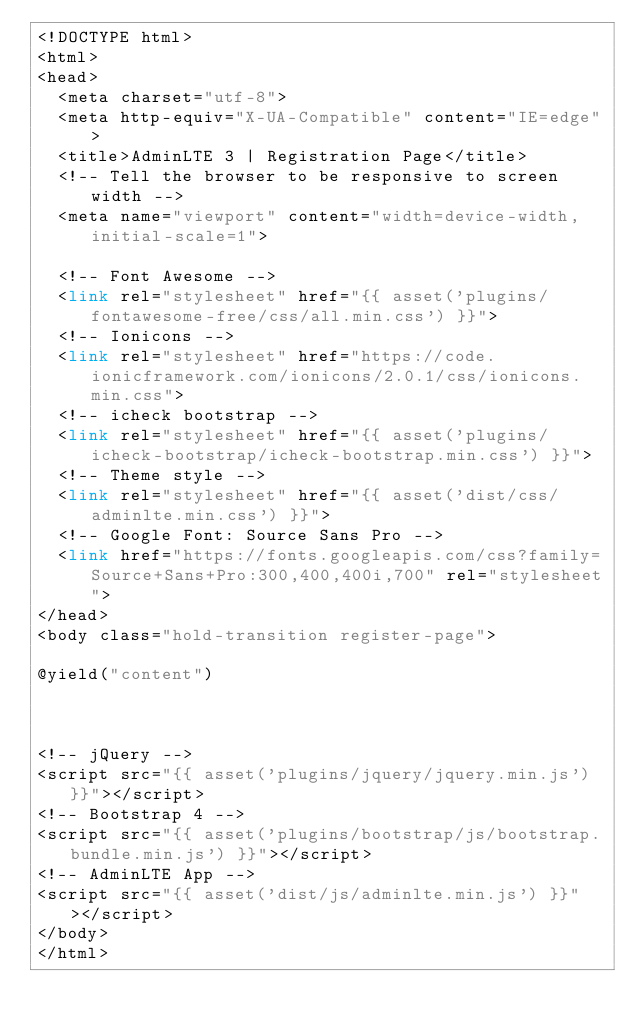Convert code to text. <code><loc_0><loc_0><loc_500><loc_500><_PHP_><!DOCTYPE html>
<html>
<head>
  <meta charset="utf-8">
  <meta http-equiv="X-UA-Compatible" content="IE=edge">
  <title>AdminLTE 3 | Registration Page</title>
  <!-- Tell the browser to be responsive to screen width -->
  <meta name="viewport" content="width=device-width, initial-scale=1">

  <!-- Font Awesome -->
  <link rel="stylesheet" href="{{ asset('plugins/fontawesome-free/css/all.min.css') }}">
  <!-- Ionicons -->
  <link rel="stylesheet" href="https://code.ionicframework.com/ionicons/2.0.1/css/ionicons.min.css">
  <!-- icheck bootstrap -->
  <link rel="stylesheet" href="{{ asset('plugins/icheck-bootstrap/icheck-bootstrap.min.css') }}">
  <!-- Theme style -->
  <link rel="stylesheet" href="{{ asset('dist/css/adminlte.min.css') }}">
  <!-- Google Font: Source Sans Pro -->
  <link href="https://fonts.googleapis.com/css?family=Source+Sans+Pro:300,400,400i,700" rel="stylesheet">
</head>
<body class="hold-transition register-page">

@yield("content")



<!-- jQuery -->
<script src="{{ asset('plugins/jquery/jquery.min.js') }}"></script>
<!-- Bootstrap 4 -->
<script src="{{ asset('plugins/bootstrap/js/bootstrap.bundle.min.js') }}"></script>
<!-- AdminLTE App -->
<script src="{{ asset('dist/js/adminlte.min.js') }}"></script>
</body>
</html>
</code> 